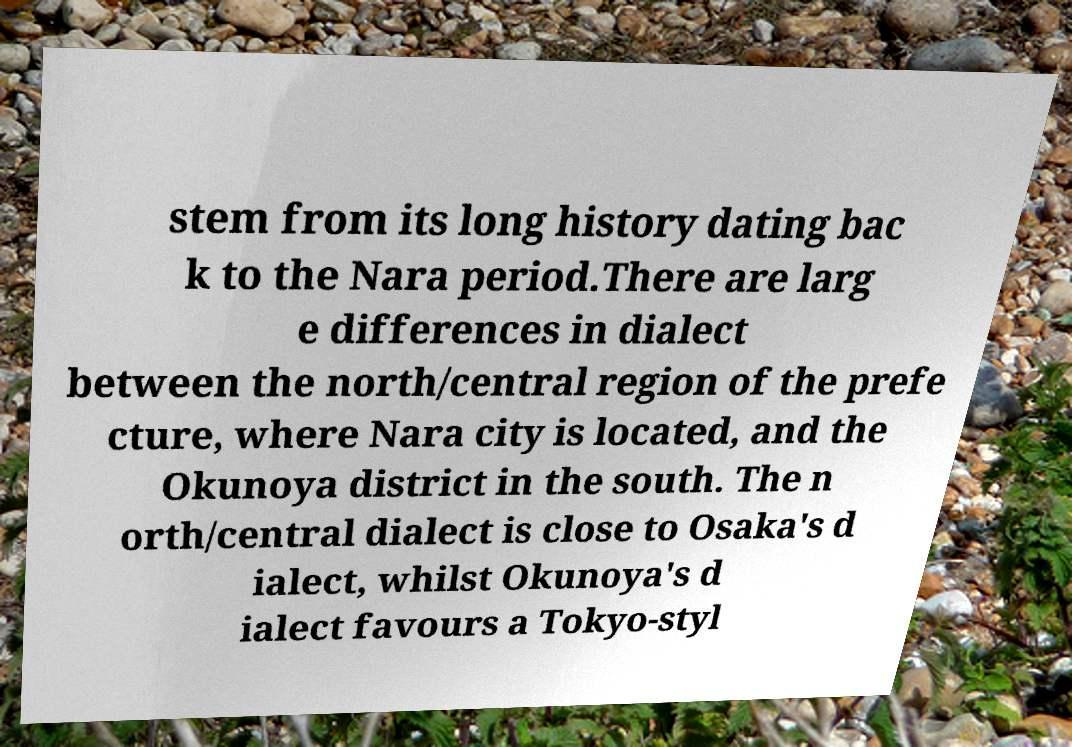Please read and relay the text visible in this image. What does it say? stem from its long history dating bac k to the Nara period.There are larg e differences in dialect between the north/central region of the prefe cture, where Nara city is located, and the Okunoya district in the south. The n orth/central dialect is close to Osaka's d ialect, whilst Okunoya's d ialect favours a Tokyo-styl 